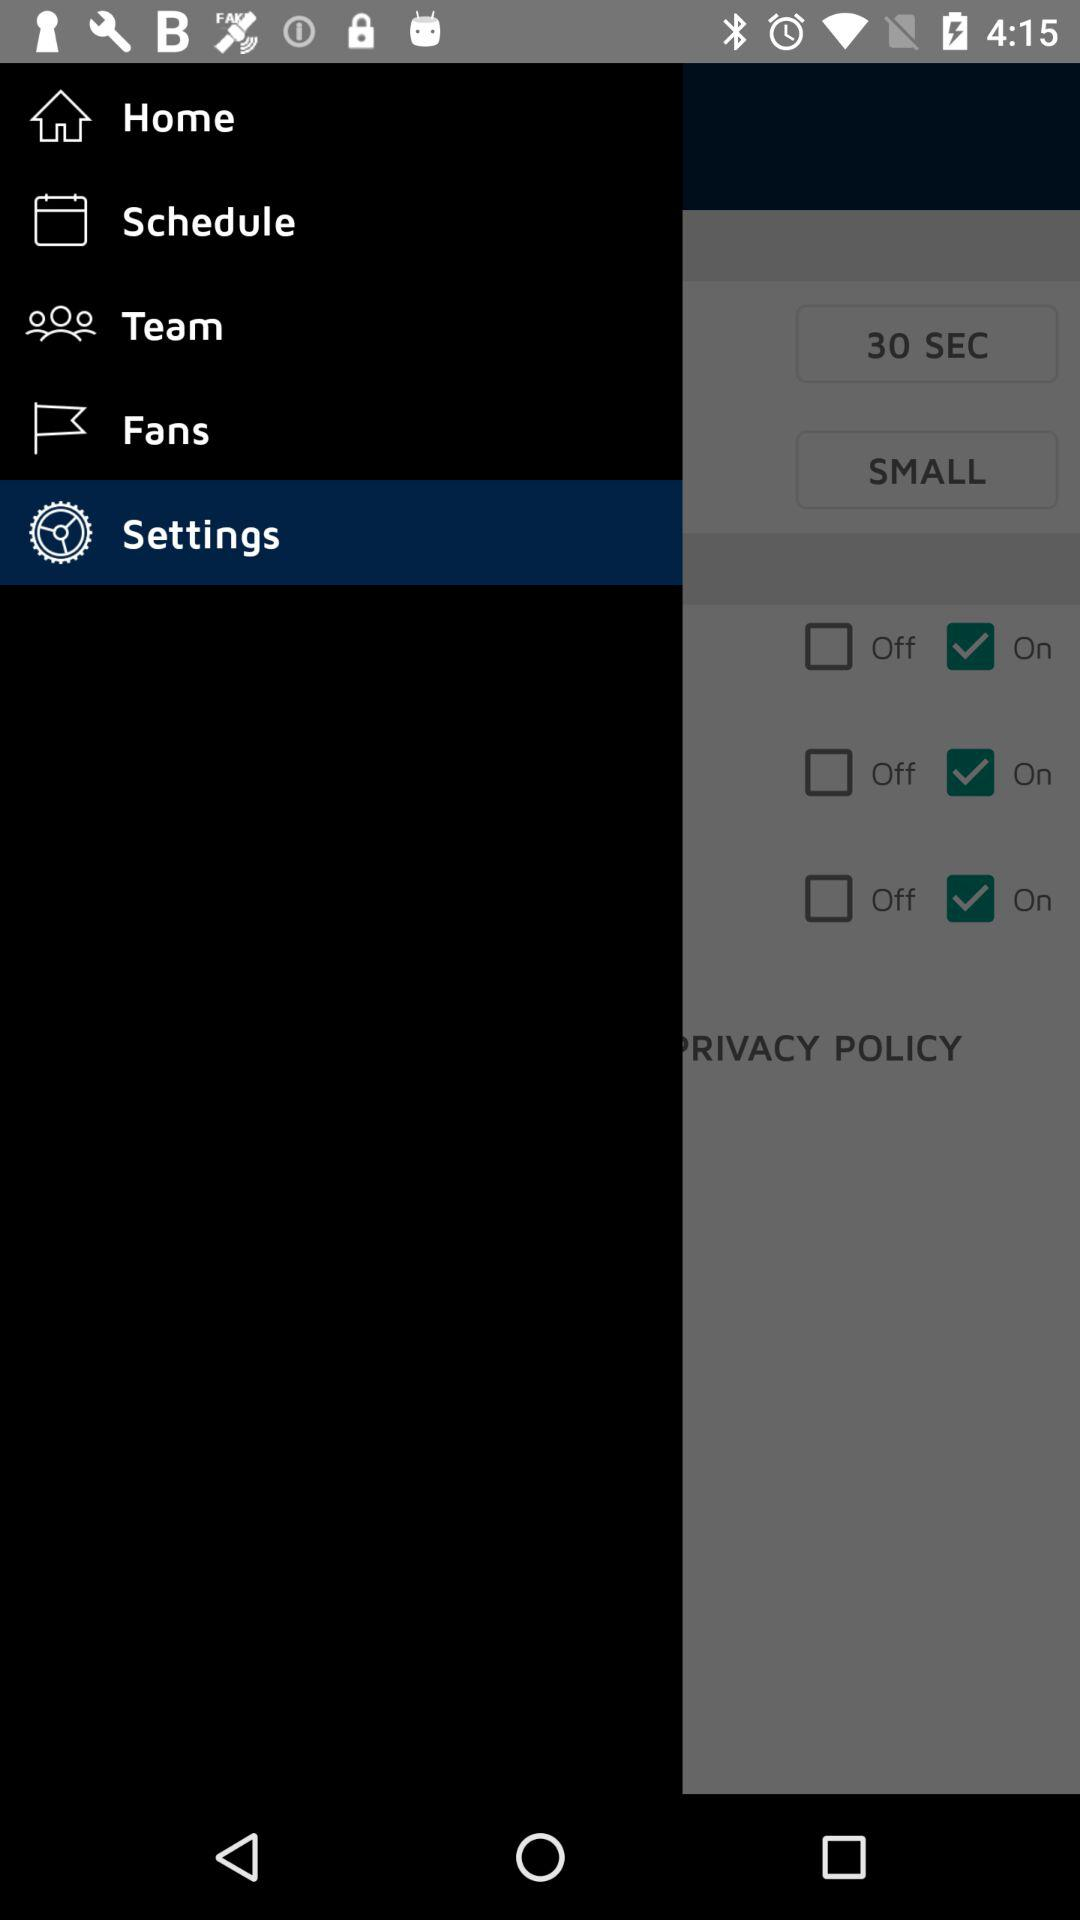Which item has been selected? The item "Settings" has been selected. 